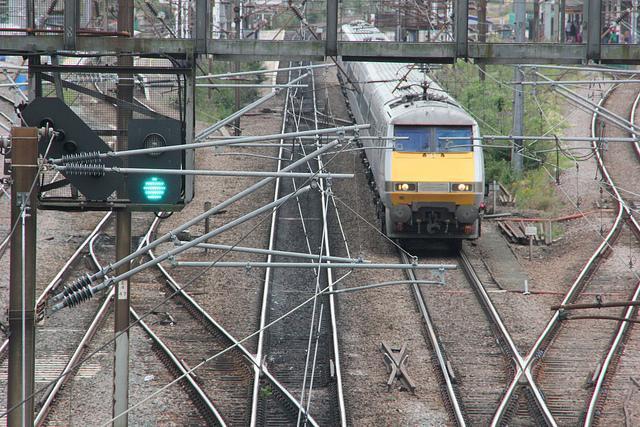How many traffic lights are there?
Give a very brief answer. 2. How many birds are standing on the sidewalk?
Give a very brief answer. 0. 